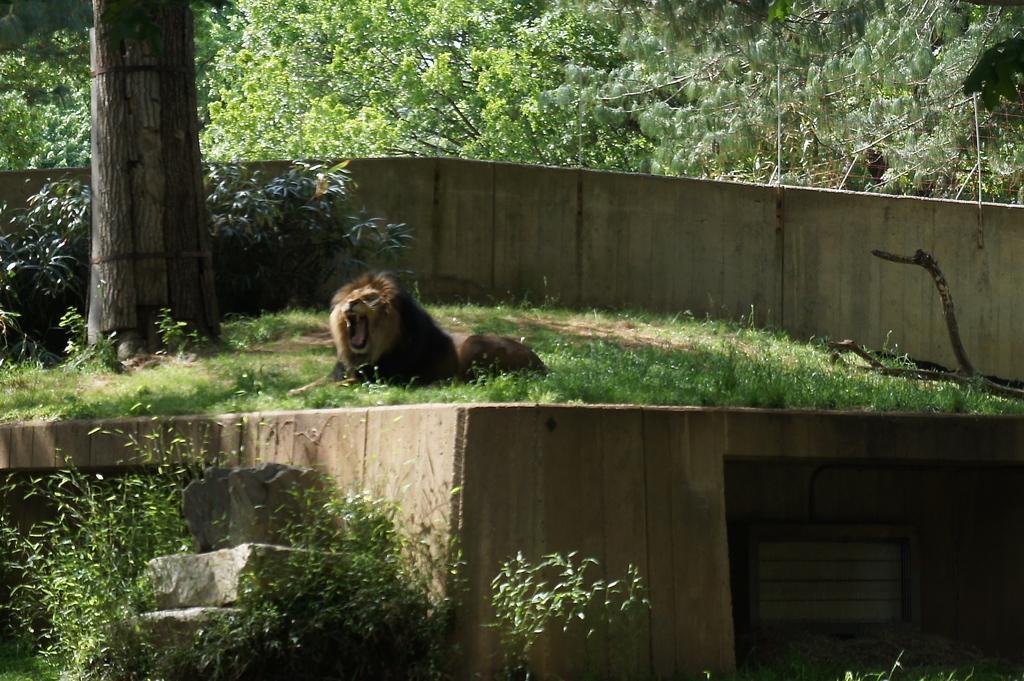Please provide a concise description of this image. In this image on the ground there is a lion. On the ground there are plants, trees. This is a boundary. In the background there are trees. 